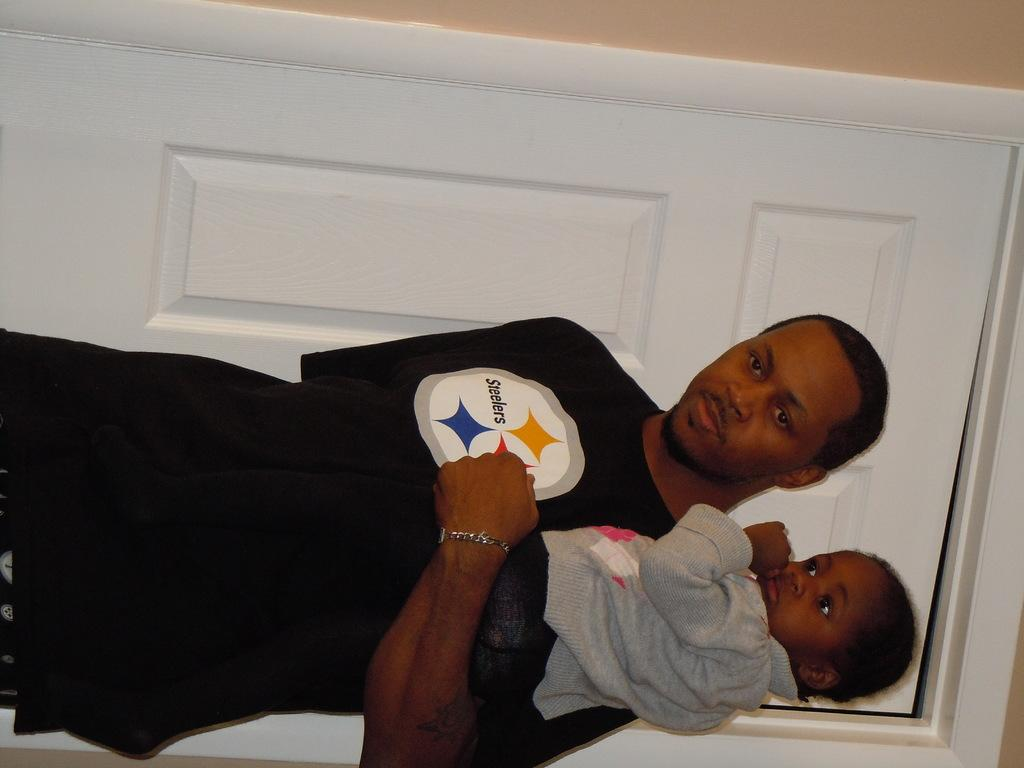What is the primary subject of the image? There is a person standing in the image. What is the person doing in the image? The person is holding a child in his hand. What architectural feature can be seen in the image? There is a door visible in the image. What is the background of the image composed of? There is a wall behind the person. What type of cheese is being used to stitch the wound on the child's hand? There is no cheese or wound present in the image. 